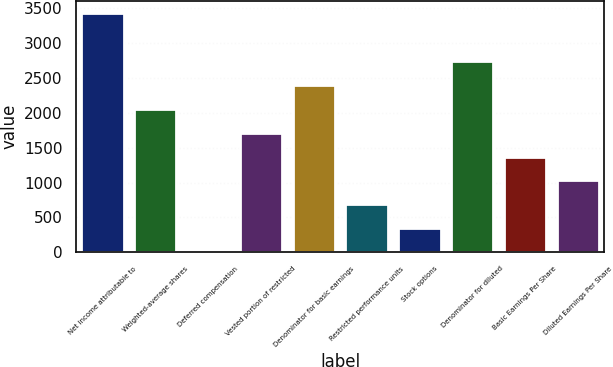Convert chart. <chart><loc_0><loc_0><loc_500><loc_500><bar_chart><fcel>Net income attributable to<fcel>Weighted-average shares<fcel>Deferred compensation<fcel>Vested portion of restricted<fcel>Denominator for basic earnings<fcel>Restricted performance units<fcel>Stock options<fcel>Denominator for diluted<fcel>Basic Earnings Per Share<fcel>Diluted Earnings Per Share<nl><fcel>3431<fcel>2059<fcel>1<fcel>1716<fcel>2402<fcel>687<fcel>344<fcel>2745<fcel>1373<fcel>1030<nl></chart> 